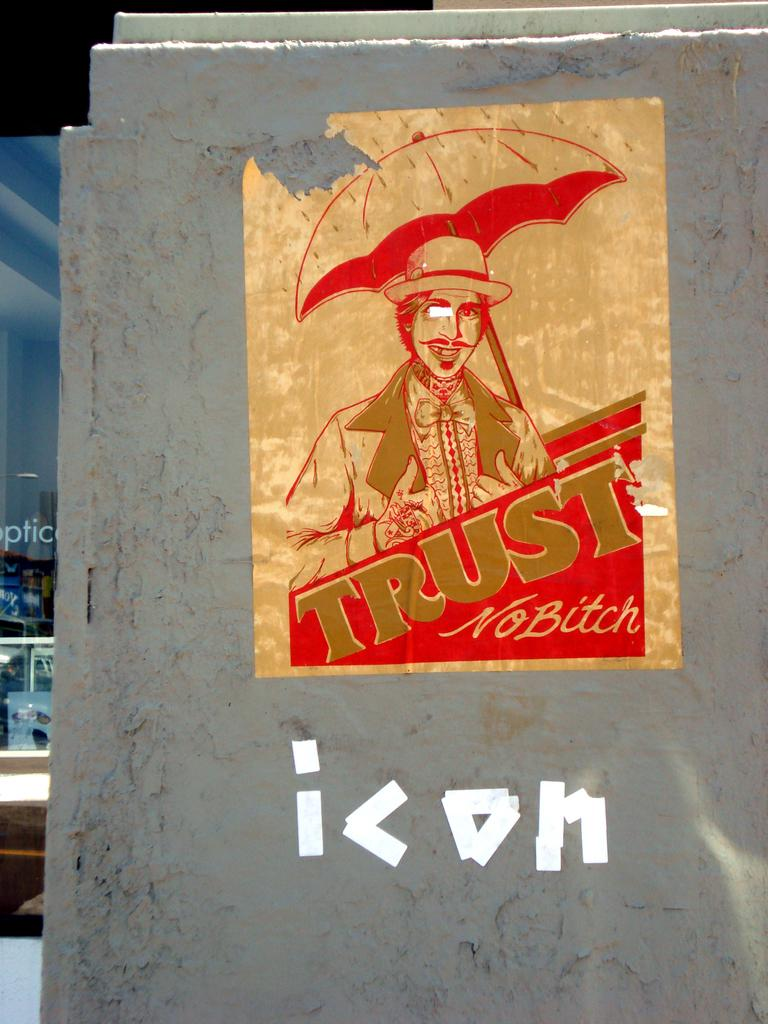<image>
Describe the image concisely. a paper on a wall that has the word trust on it 